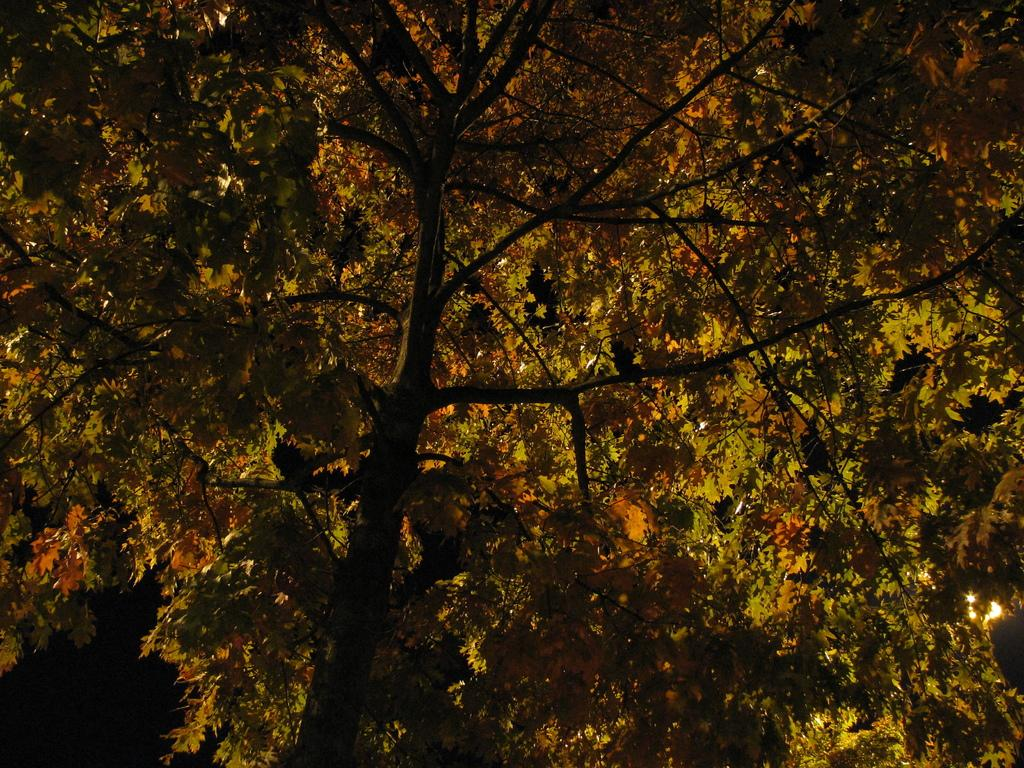What type of vegetation can be seen in the image? There are trees in the image. Where is the light located in the image? The light is on the right side of the image. What time of day was the image taken? The image was taken during night time, as it is dark. What type of grass is growing on the end of the light in the image? There is no grass present in the image, and the light does not have an end. 